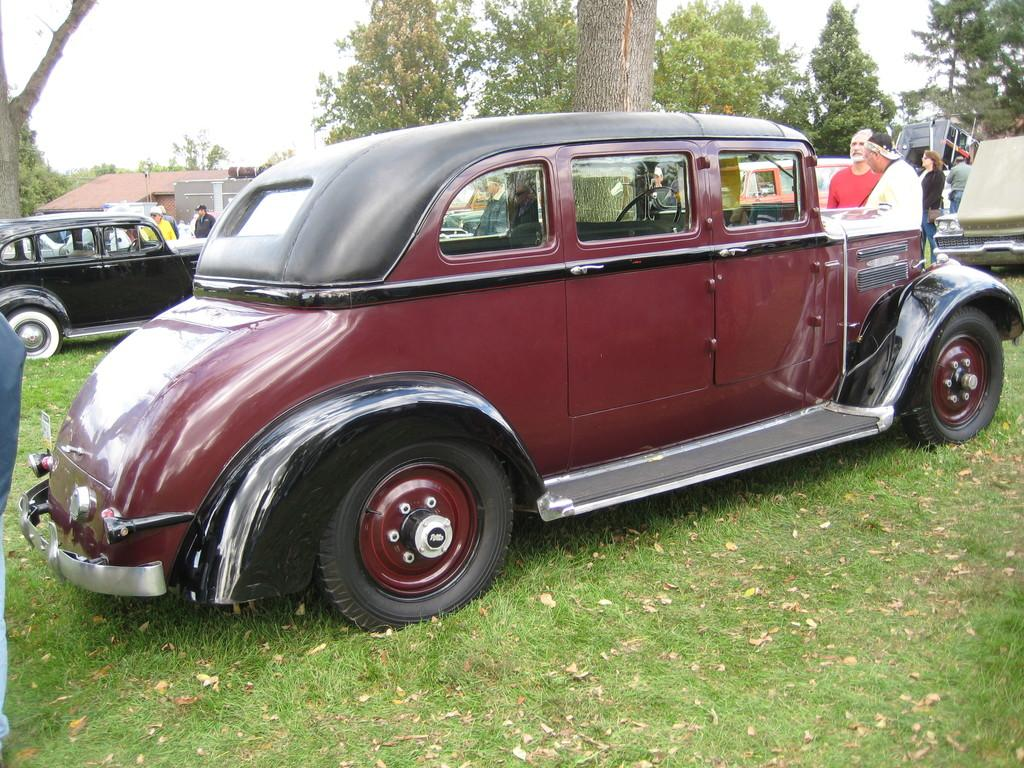What type of natural debris can be seen on the grass in the image? There are dried leaves on the grass in the image. What types of man-made objects are visible in the image? There are vehicles and some objects visible in the image. What type of vegetation is present in the image? There are trees in the image. What type of structure is present in the image? There is a building in the image. What are the people in the image doing? There is a group of people standing in the image. What is visible in the background of the image? The sky is visible in the background of the image. Can you tell me how many bubbles are floating around the people in the image? There are no bubbles present in the image. What type of conflict is occurring between the people in the image? There is no fight or conflict depicted in the image; the people are simply standing. 